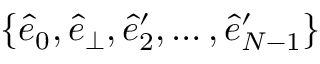<formula> <loc_0><loc_0><loc_500><loc_500>\{ \hat { e } _ { 0 } , \hat { e } _ { \perp } , \hat { e } _ { 2 } ^ { \prime } , \dots , \hat { e } _ { N - 1 } ^ { \prime } \}</formula> 